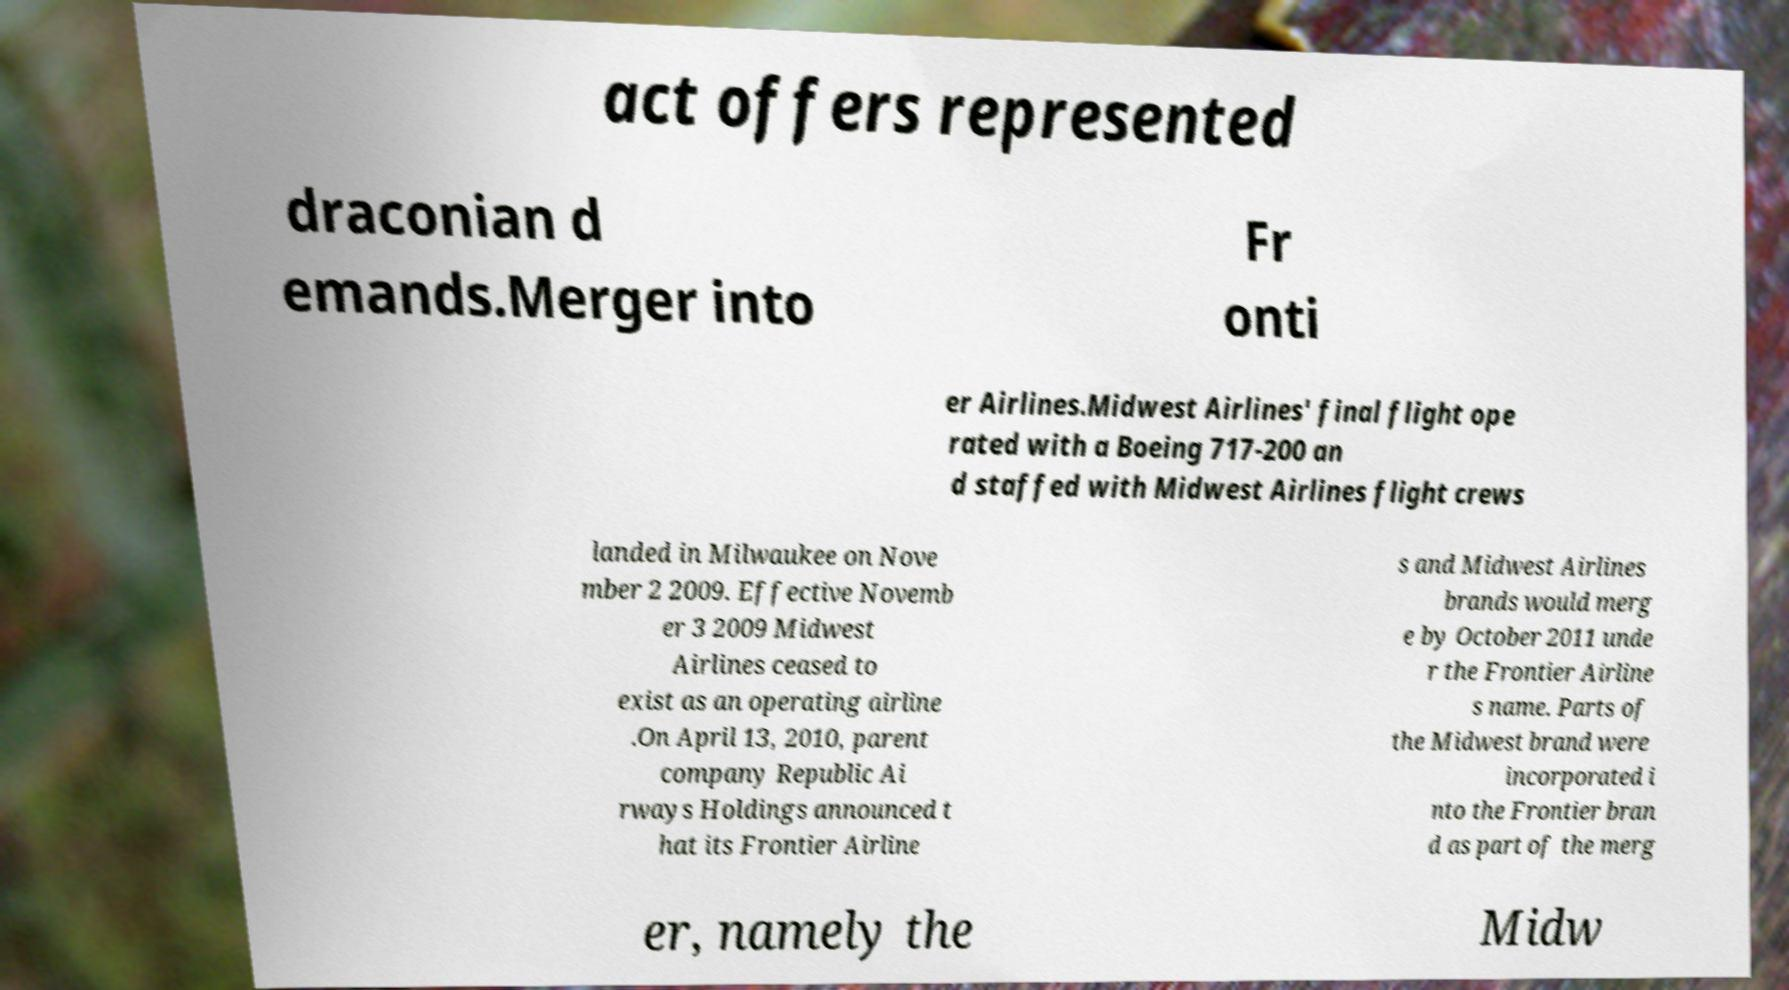What messages or text are displayed in this image? I need them in a readable, typed format. act offers represented draconian d emands.Merger into Fr onti er Airlines.Midwest Airlines' final flight ope rated with a Boeing 717-200 an d staffed with Midwest Airlines flight crews landed in Milwaukee on Nove mber 2 2009. Effective Novemb er 3 2009 Midwest Airlines ceased to exist as an operating airline .On April 13, 2010, parent company Republic Ai rways Holdings announced t hat its Frontier Airline s and Midwest Airlines brands would merg e by October 2011 unde r the Frontier Airline s name. Parts of the Midwest brand were incorporated i nto the Frontier bran d as part of the merg er, namely the Midw 